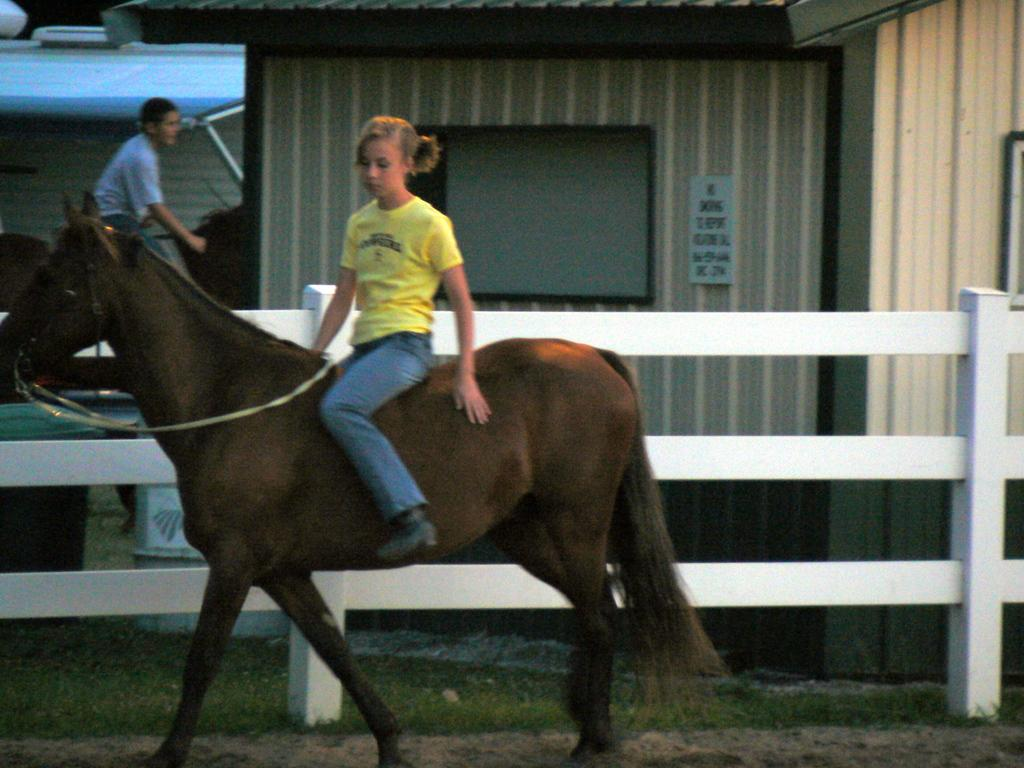How many people are in the image? There are two people in the image. What are the people doing in the image? The people are sitting on horses. Where are the horses located in the image? The horses are on the ground. What can be seen in the background of the image? There is a fence in the image. What type of vegetation is visible in the image? Grass is visible in the image. What else is present in the image besides the people and horses? Seeds, a name board, a dustbin, and an object are present in the image. What type of scent can be detected from the sleet in the image? There is no sleet present in the image, so it is not possible to detect any scent from it. 